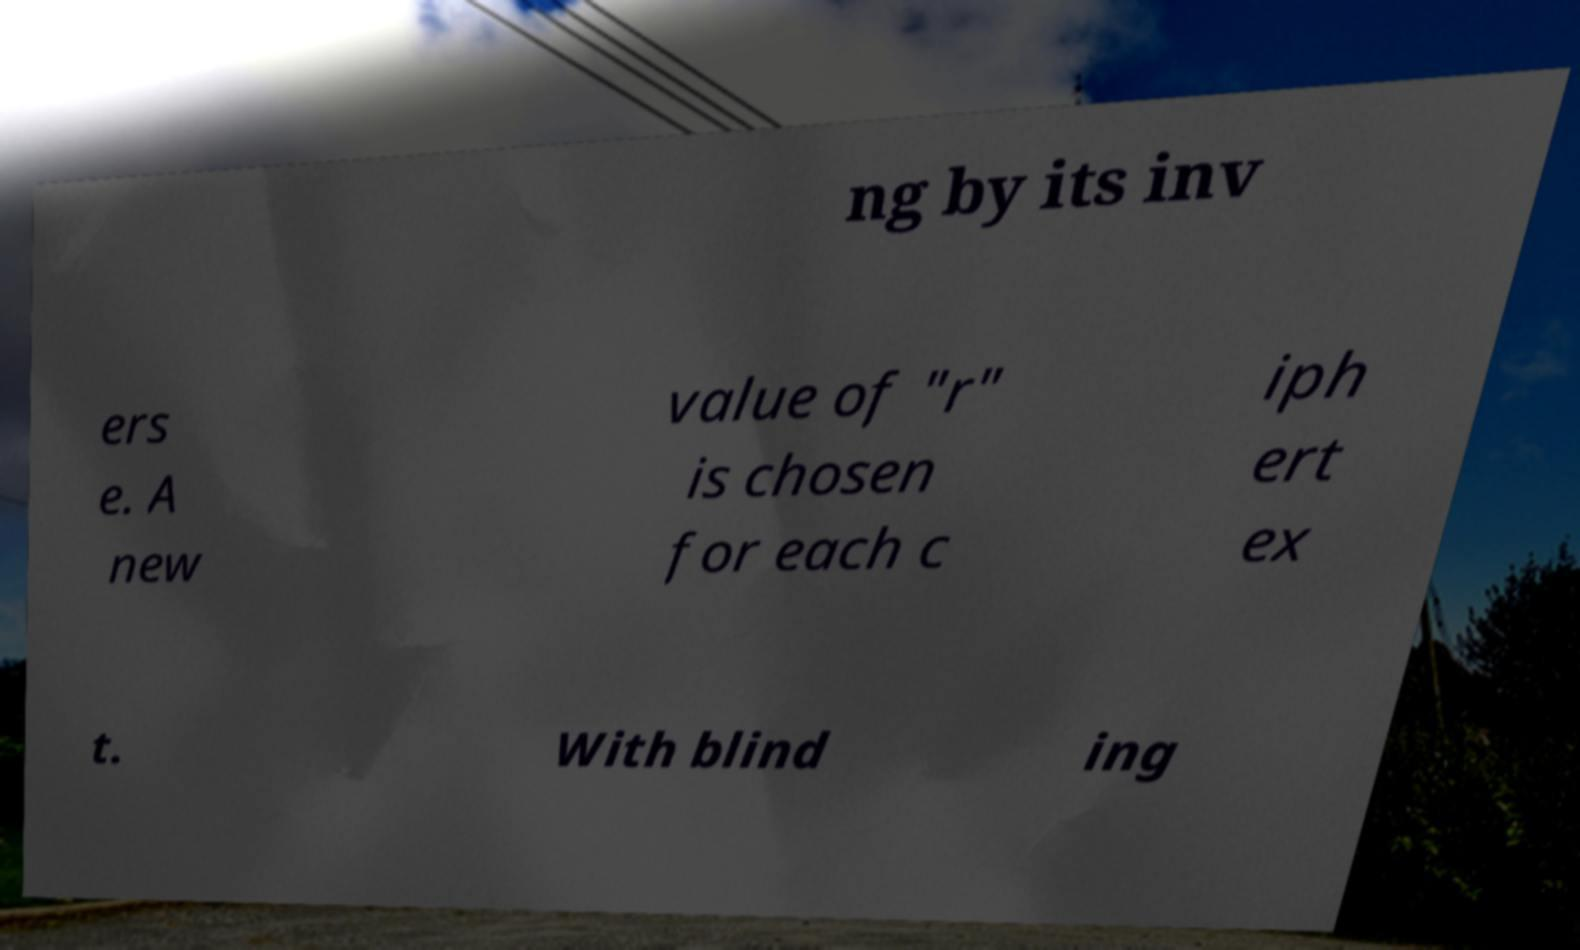Please identify and transcribe the text found in this image. ng by its inv ers e. A new value of "r" is chosen for each c iph ert ex t. With blind ing 